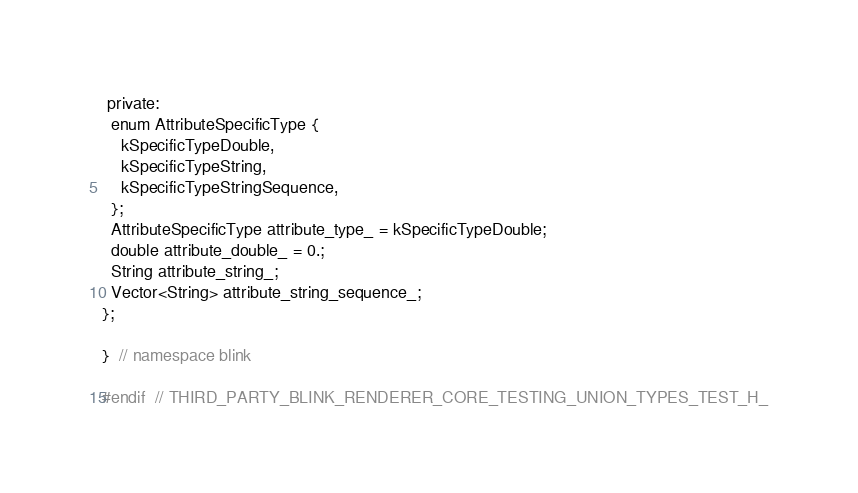<code> <loc_0><loc_0><loc_500><loc_500><_C_> private:
  enum AttributeSpecificType {
    kSpecificTypeDouble,
    kSpecificTypeString,
    kSpecificTypeStringSequence,
  };
  AttributeSpecificType attribute_type_ = kSpecificTypeDouble;
  double attribute_double_ = 0.;
  String attribute_string_;
  Vector<String> attribute_string_sequence_;
};

}  // namespace blink

#endif  // THIRD_PARTY_BLINK_RENDERER_CORE_TESTING_UNION_TYPES_TEST_H_
</code> 